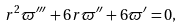Convert formula to latex. <formula><loc_0><loc_0><loc_500><loc_500>r ^ { 2 } \varpi ^ { \prime \prime \prime } + 6 r \varpi ^ { \prime \prime } + 6 \varpi ^ { \prime } = 0 ,</formula> 